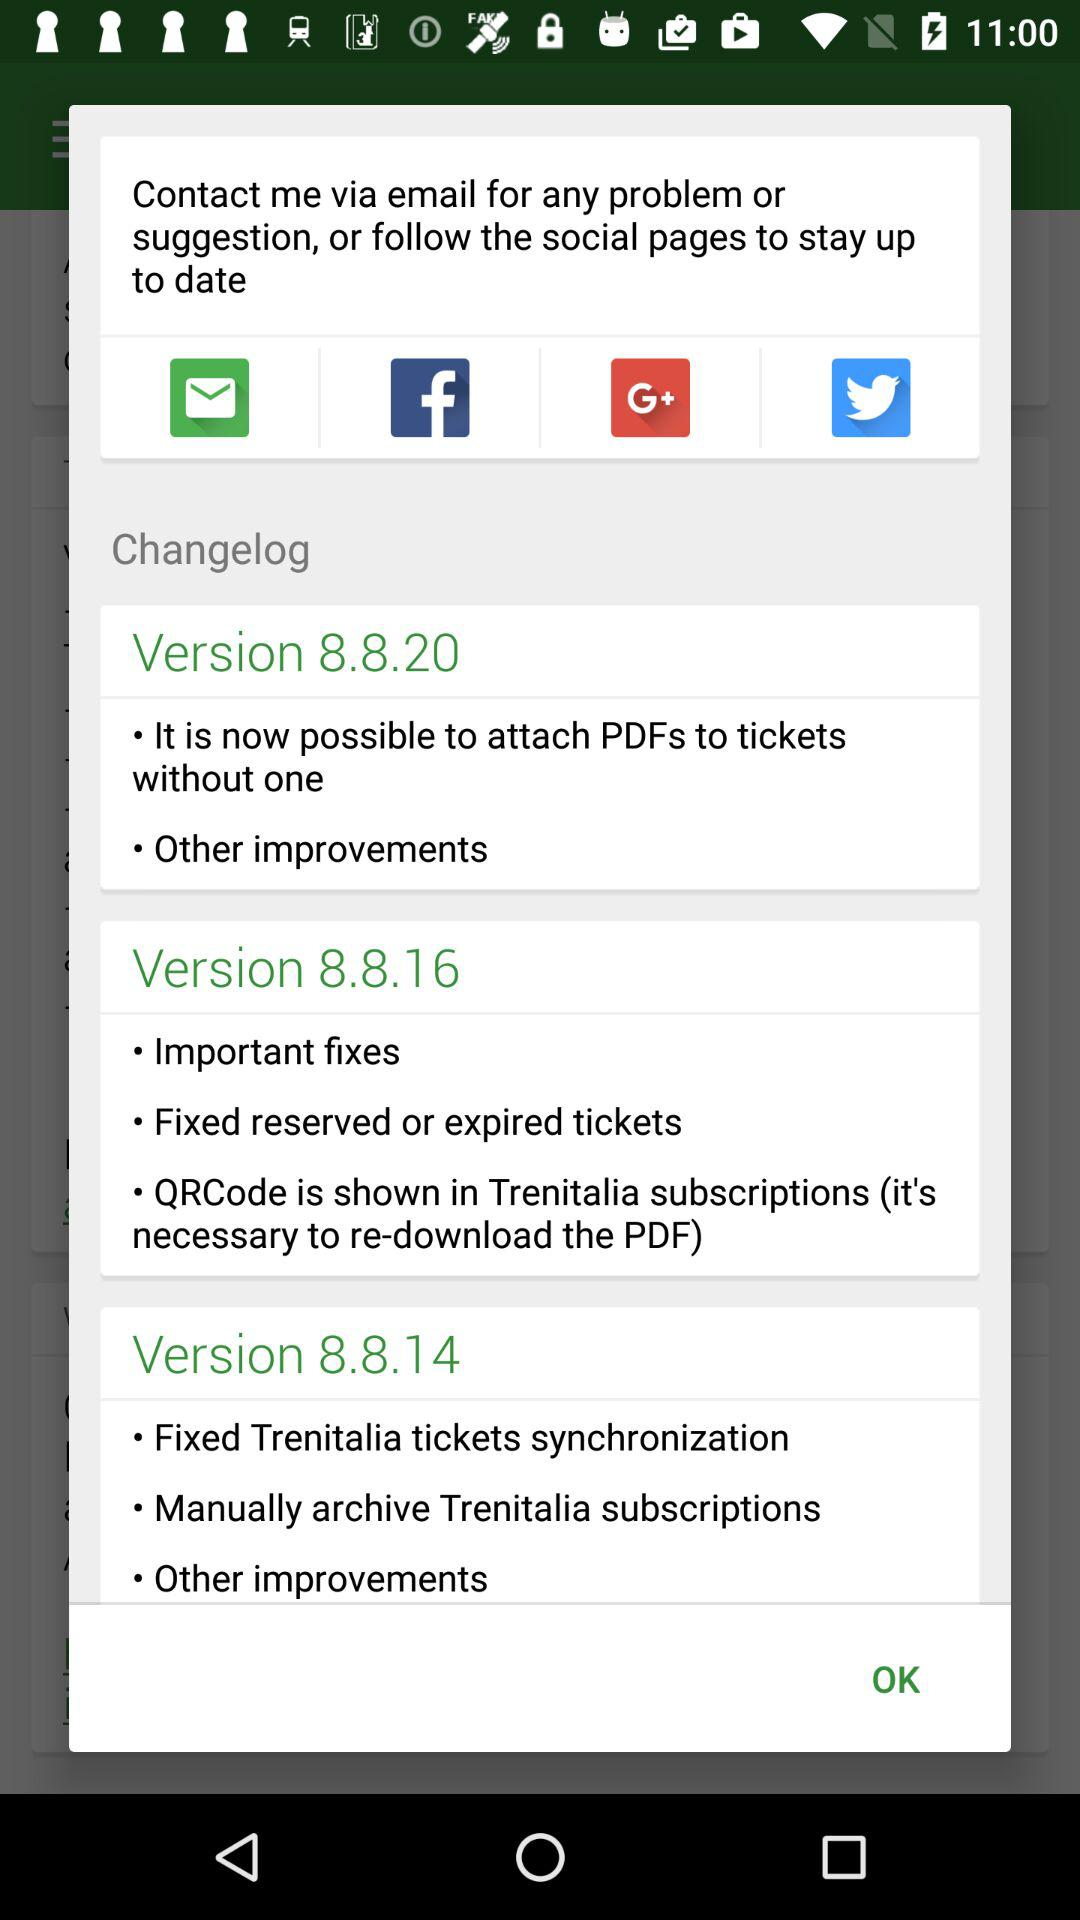What are the features of version 8.8.20? The features are "It is now possible to attach PDFs to tickets without one" and "Other improvements". 